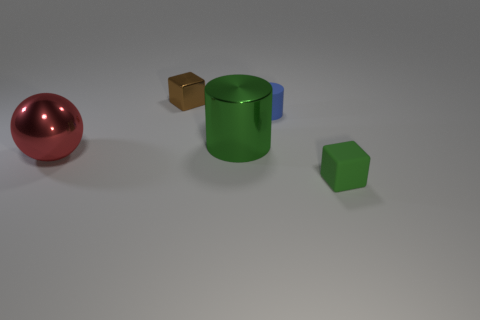Are there fewer tiny rubber cylinders that are in front of the tiny green block than yellow cylinders?
Your response must be concise. No. What number of other objects are there of the same shape as the green metal thing?
Keep it short and to the point. 1. What number of objects are either things that are to the left of the rubber block or things behind the large green object?
Offer a terse response. 4. There is a object that is in front of the green cylinder and to the right of the metallic cube; what is its size?
Give a very brief answer. Small. There is a matte object that is in front of the small cylinder; does it have the same shape as the blue rubber object?
Your answer should be compact. No. What size is the shiny object that is left of the tiny block that is behind the small block that is in front of the tiny blue object?
Keep it short and to the point. Large. What size is the thing that is the same color as the large cylinder?
Your answer should be compact. Small. How many things are brown metal things or large brown rubber balls?
Ensure brevity in your answer.  1. What shape is the tiny object that is both behind the red object and in front of the small brown object?
Offer a terse response. Cylinder. There is a red thing; is its shape the same as the big object right of the tiny brown metal thing?
Make the answer very short. No. 